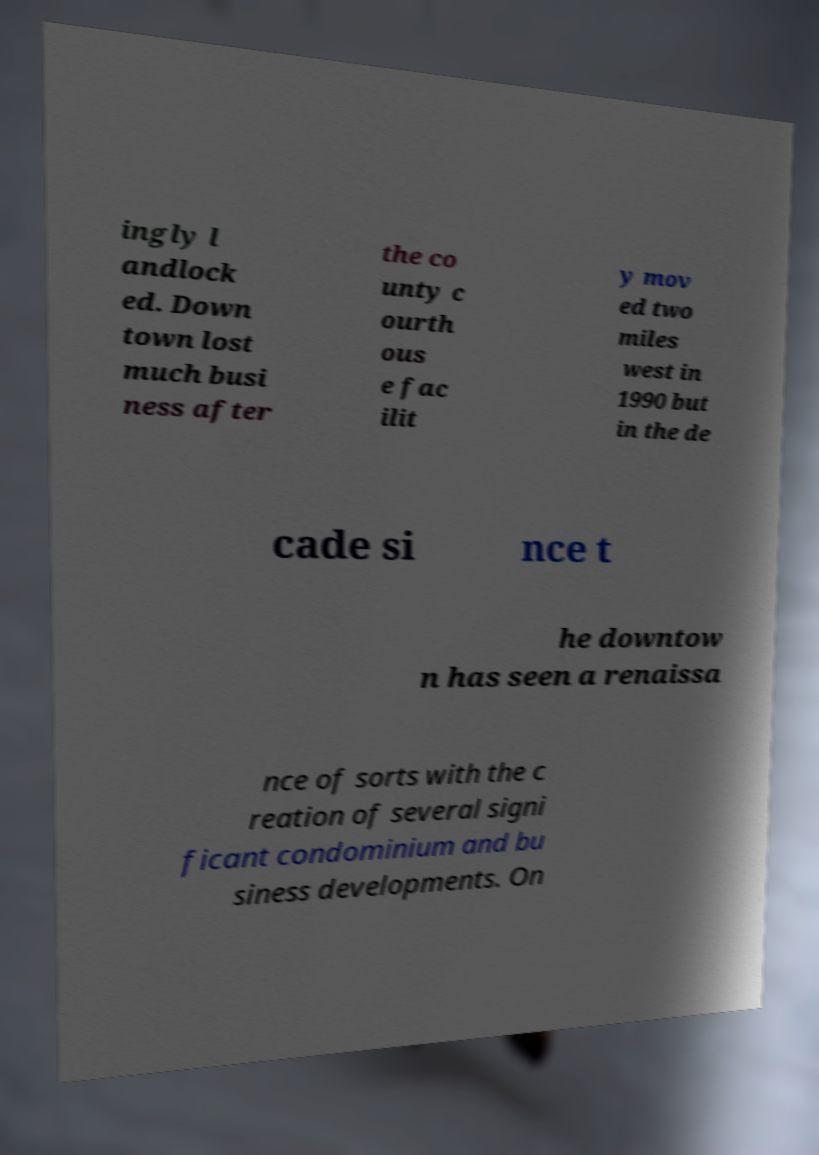For documentation purposes, I need the text within this image transcribed. Could you provide that? ingly l andlock ed. Down town lost much busi ness after the co unty c ourth ous e fac ilit y mov ed two miles west in 1990 but in the de cade si nce t he downtow n has seen a renaissa nce of sorts with the c reation of several signi ficant condominium and bu siness developments. On 